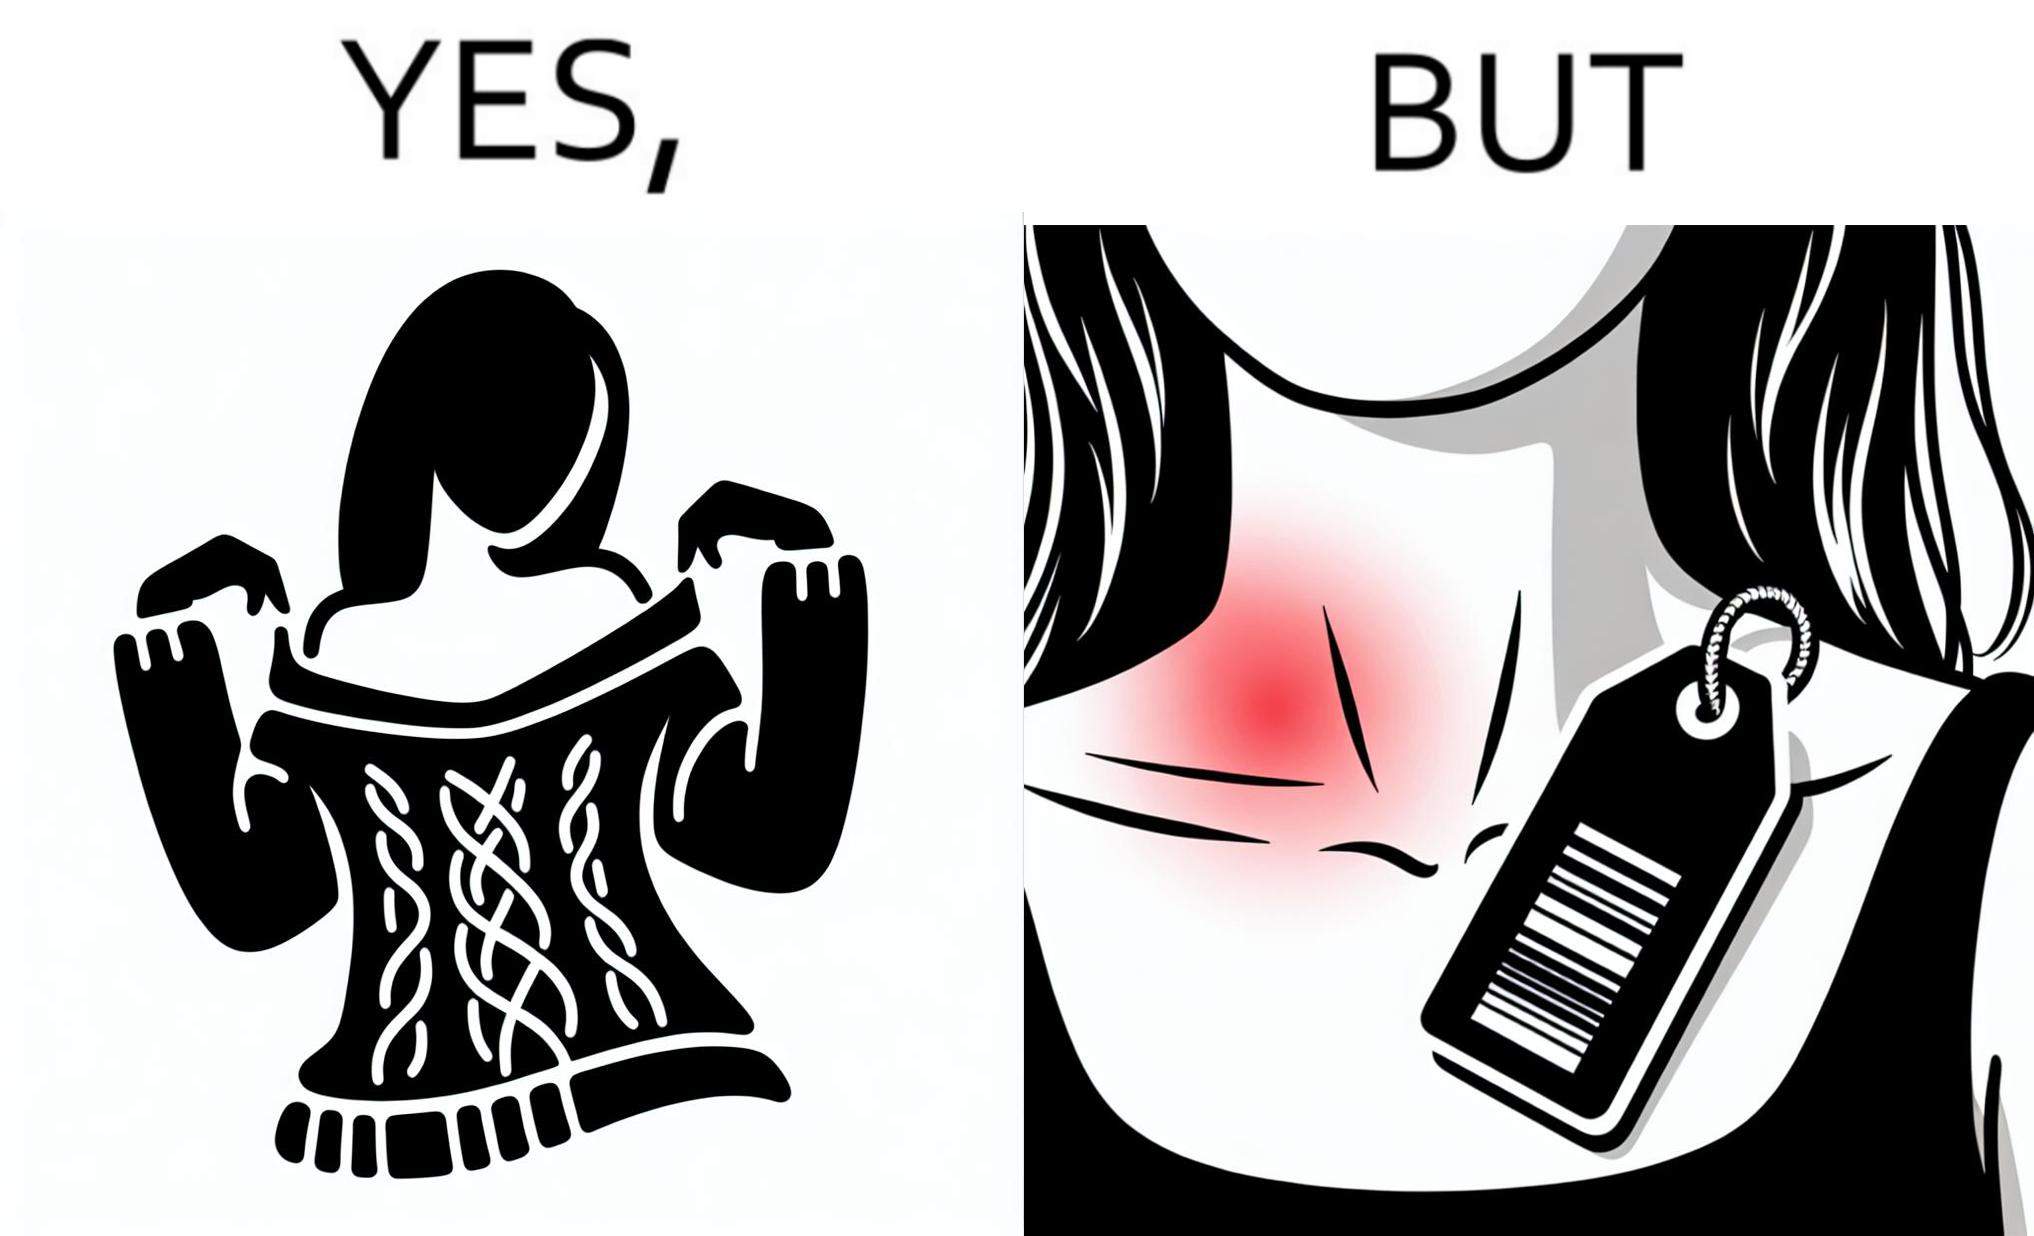What does this image depict? The images are funny since it shows how even though sweaters and other clothings provide much comfort, a tiny manufacturers tag ends up causing the user a lot of discomfort due to constant scratching 